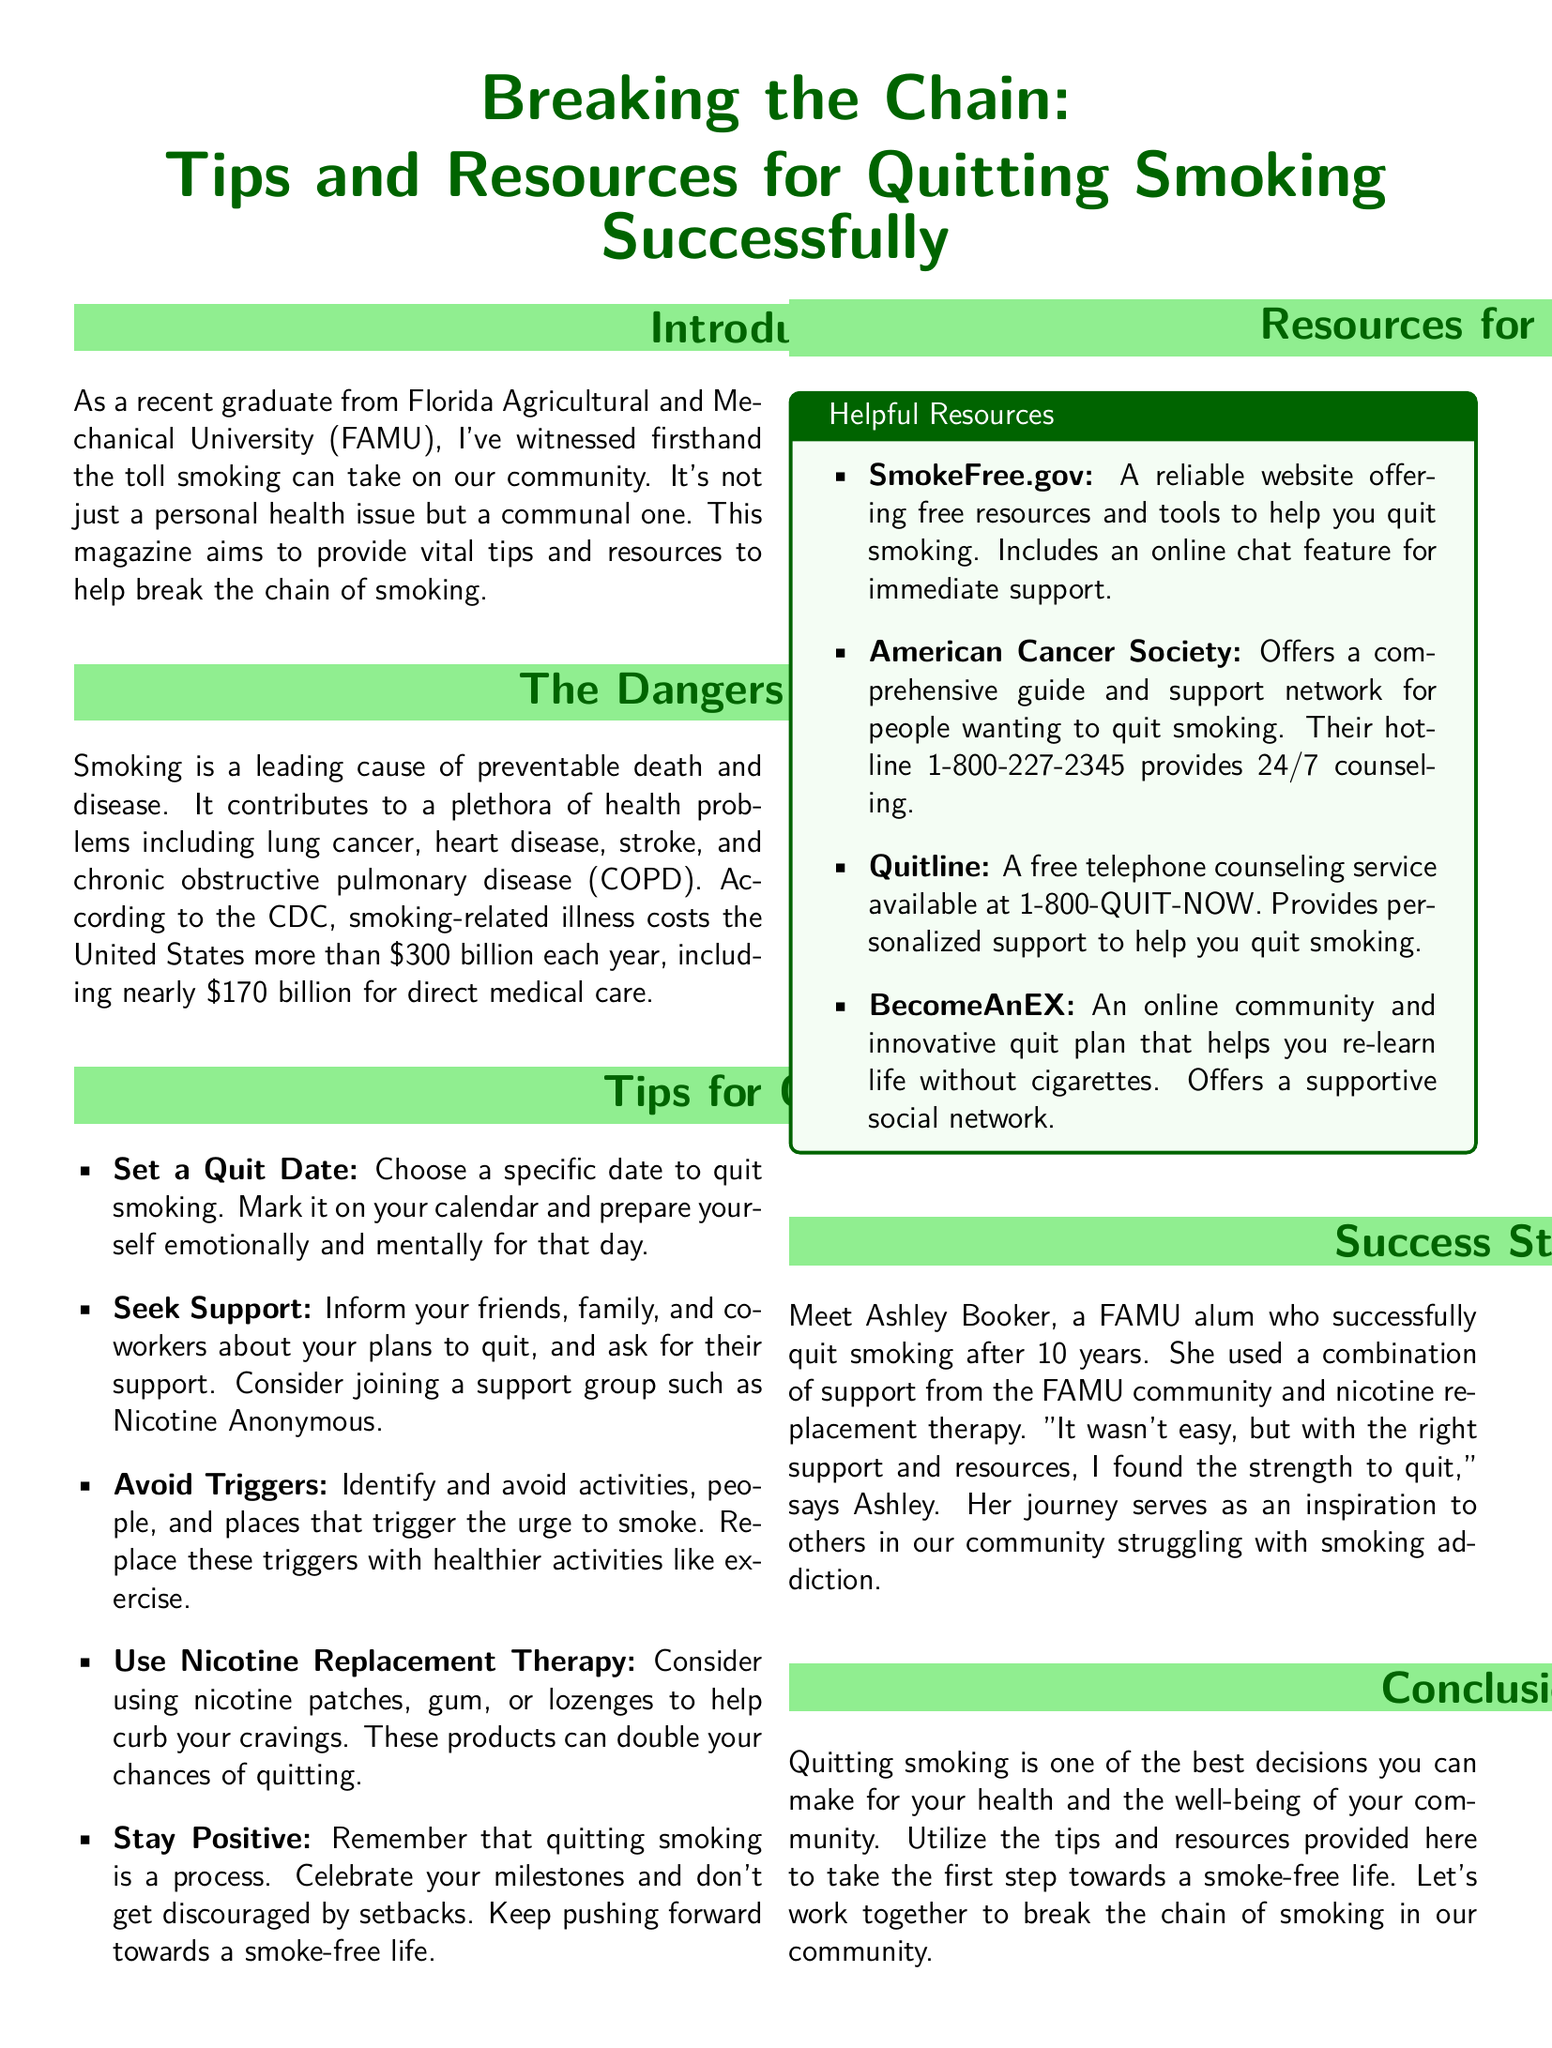what is the main topic of the magazine? The main topic is the tips and resources for quitting smoking successfully.
Answer: tips and resources for quitting smoking successfully how much does smoking-related illness cost the United States annually? The document states that smoking-related illness costs the United States more than $300 billion each year.
Answer: $300 billion what is one method suggested for overcoming smoking triggers? The article suggests replacing triggers with healthier activities like exercise.
Answer: healthier activities who is an example of a successful quitter mentioned in the document? The document provides an example of Ashley Booker, a FAMU alum who successfully quit smoking.
Answer: Ashley Booker what is the hotline number for the American Cancer Society? The hotline number is provided for counseling support.
Answer: 1-800-227-2345 what is the purpose of the SmokeFree.gov website? The website offers free resources and tools to help individuals quit smoking.
Answer: free resources and tools how many years did Ashley Booker smoke before quitting? According to the document, Ashley smoked for 10 years before quitting.
Answer: 10 years what color is used predominantly for the title section of the magazine? The title section is colored in a shade of green as indicated by the color definitions.
Answer: green what type of support does Quitline provide? Quitline provides personalized support for individuals trying to quit smoking.
Answer: personalized support what emotional state does the document suggest one should prepare for on the quit date? The document advises to prepare emotionally and mentally for the quit date.
Answer: emotionally and mentally 